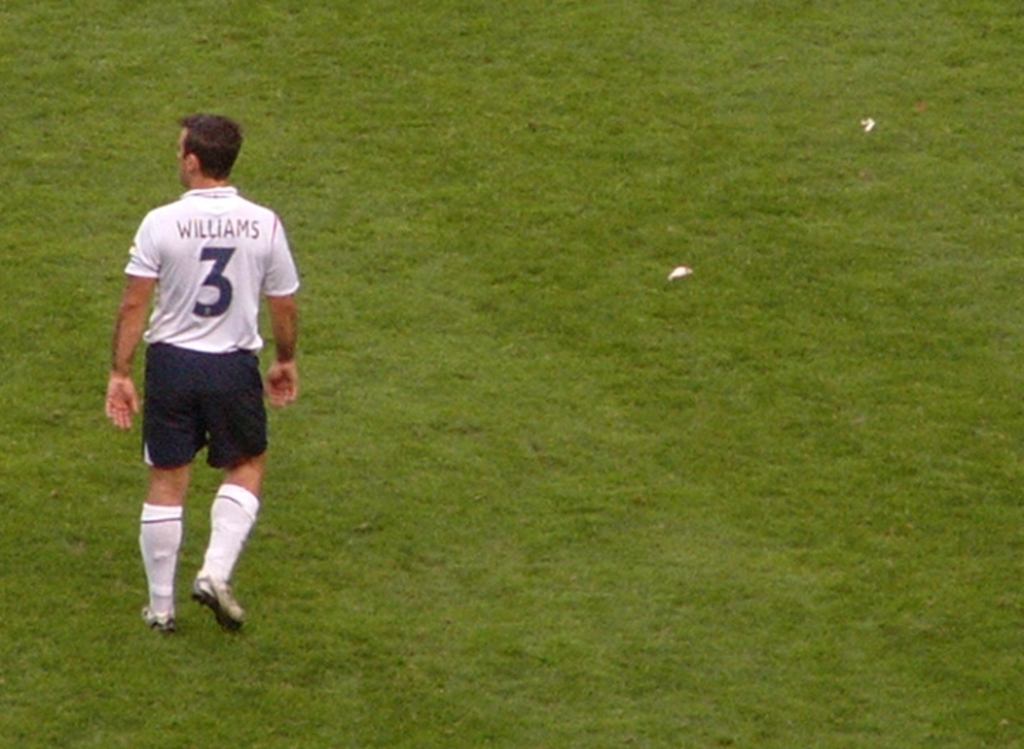Describe the atmosphere of the setting where this athlete is, and what does this imply about the moment captured? The setting appears serene and somewhat isolated, with a focus on the athlete named 'Williams'. This implies a moment of brief pause in the game, possibly during a stop in play or as the player observes the ongoing action. The expanse of the unoccupied field suggests a quiet instant, contrasting with the typical high energy of a soccer match. 